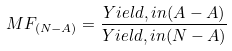<formula> <loc_0><loc_0><loc_500><loc_500>M F _ { ( N - A ) } = \frac { Y i e l d , i n ( A - A ) } { Y i e l d , i n ( N - A ) }</formula> 